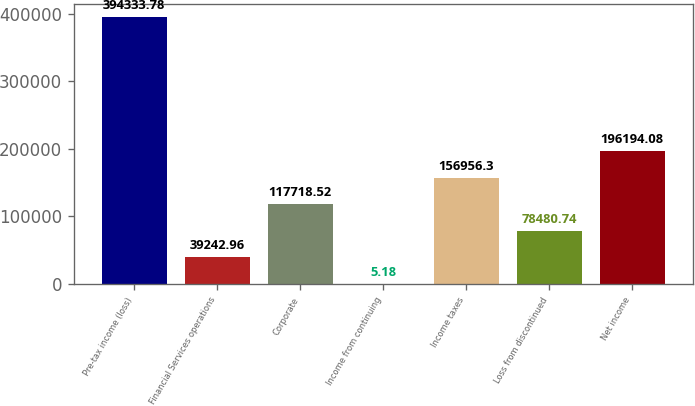Convert chart. <chart><loc_0><loc_0><loc_500><loc_500><bar_chart><fcel>Pre-tax income (loss)<fcel>Financial Services operations<fcel>Corporate<fcel>Income from continuing<fcel>Income taxes<fcel>Loss from discontinued<fcel>Net income<nl><fcel>394334<fcel>39243<fcel>117719<fcel>5.18<fcel>156956<fcel>78480.7<fcel>196194<nl></chart> 